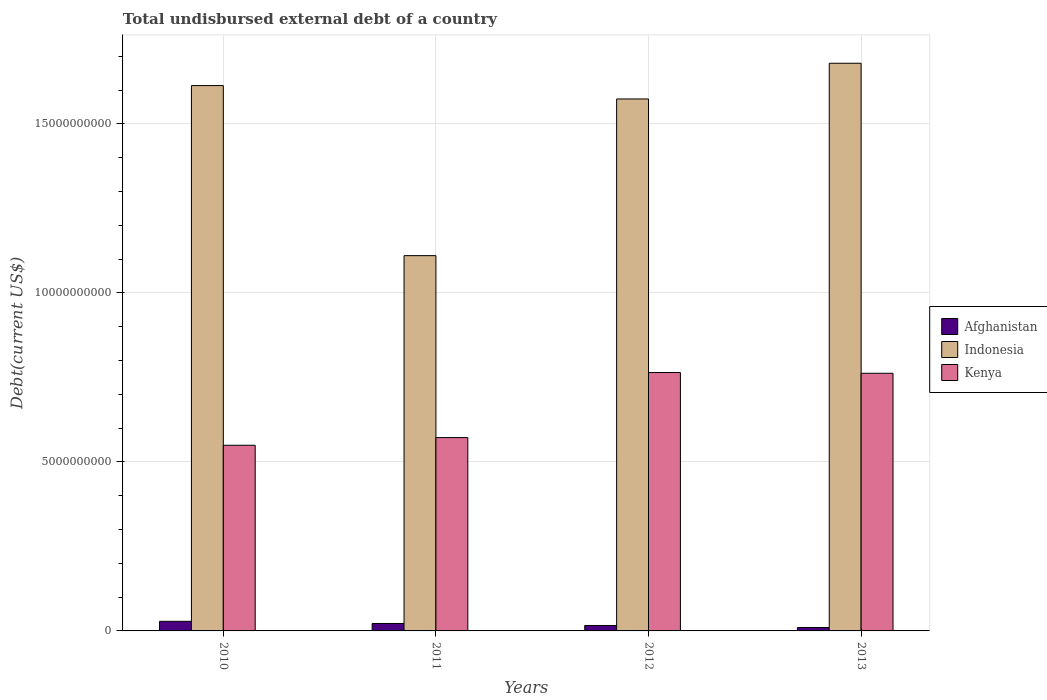How many different coloured bars are there?
Your response must be concise. 3. How many groups of bars are there?
Provide a short and direct response. 4. Are the number of bars per tick equal to the number of legend labels?
Ensure brevity in your answer.  Yes. Are the number of bars on each tick of the X-axis equal?
Ensure brevity in your answer.  Yes. How many bars are there on the 1st tick from the left?
Offer a very short reply. 3. How many bars are there on the 2nd tick from the right?
Your response must be concise. 3. In how many cases, is the number of bars for a given year not equal to the number of legend labels?
Offer a terse response. 0. What is the total undisbursed external debt in Afghanistan in 2010?
Keep it short and to the point. 2.84e+08. Across all years, what is the maximum total undisbursed external debt in Afghanistan?
Keep it short and to the point. 2.84e+08. Across all years, what is the minimum total undisbursed external debt in Afghanistan?
Ensure brevity in your answer.  1.02e+08. In which year was the total undisbursed external debt in Afghanistan maximum?
Your answer should be very brief. 2010. What is the total total undisbursed external debt in Kenya in the graph?
Keep it short and to the point. 2.65e+1. What is the difference between the total undisbursed external debt in Afghanistan in 2010 and that in 2011?
Offer a terse response. 6.44e+07. What is the difference between the total undisbursed external debt in Kenya in 2010 and the total undisbursed external debt in Afghanistan in 2012?
Your answer should be compact. 5.33e+09. What is the average total undisbursed external debt in Indonesia per year?
Your response must be concise. 1.49e+1. In the year 2011, what is the difference between the total undisbursed external debt in Indonesia and total undisbursed external debt in Kenya?
Offer a very short reply. 5.38e+09. In how many years, is the total undisbursed external debt in Afghanistan greater than 1000000000 US$?
Keep it short and to the point. 0. What is the ratio of the total undisbursed external debt in Afghanistan in 2010 to that in 2013?
Offer a terse response. 2.8. Is the difference between the total undisbursed external debt in Indonesia in 2011 and 2013 greater than the difference between the total undisbursed external debt in Kenya in 2011 and 2013?
Offer a terse response. No. What is the difference between the highest and the second highest total undisbursed external debt in Afghanistan?
Your answer should be very brief. 6.44e+07. What is the difference between the highest and the lowest total undisbursed external debt in Kenya?
Provide a succinct answer. 2.15e+09. In how many years, is the total undisbursed external debt in Afghanistan greater than the average total undisbursed external debt in Afghanistan taken over all years?
Your response must be concise. 2. What does the 2nd bar from the left in 2010 represents?
Give a very brief answer. Indonesia. Are all the bars in the graph horizontal?
Ensure brevity in your answer.  No. How many years are there in the graph?
Offer a very short reply. 4. What is the difference between two consecutive major ticks on the Y-axis?
Provide a short and direct response. 5.00e+09. Are the values on the major ticks of Y-axis written in scientific E-notation?
Your answer should be compact. No. Does the graph contain grids?
Make the answer very short. Yes. Where does the legend appear in the graph?
Give a very brief answer. Center right. How are the legend labels stacked?
Offer a very short reply. Vertical. What is the title of the graph?
Your response must be concise. Total undisbursed external debt of a country. Does "Kyrgyz Republic" appear as one of the legend labels in the graph?
Your answer should be very brief. No. What is the label or title of the X-axis?
Offer a terse response. Years. What is the label or title of the Y-axis?
Make the answer very short. Debt(current US$). What is the Debt(current US$) of Afghanistan in 2010?
Give a very brief answer. 2.84e+08. What is the Debt(current US$) of Indonesia in 2010?
Provide a short and direct response. 1.61e+1. What is the Debt(current US$) of Kenya in 2010?
Your answer should be very brief. 5.49e+09. What is the Debt(current US$) of Afghanistan in 2011?
Your answer should be very brief. 2.20e+08. What is the Debt(current US$) in Indonesia in 2011?
Offer a very short reply. 1.11e+1. What is the Debt(current US$) in Kenya in 2011?
Ensure brevity in your answer.  5.72e+09. What is the Debt(current US$) in Afghanistan in 2012?
Make the answer very short. 1.61e+08. What is the Debt(current US$) in Indonesia in 2012?
Provide a short and direct response. 1.57e+1. What is the Debt(current US$) of Kenya in 2012?
Your answer should be very brief. 7.64e+09. What is the Debt(current US$) in Afghanistan in 2013?
Your answer should be compact. 1.02e+08. What is the Debt(current US$) in Indonesia in 2013?
Your answer should be compact. 1.68e+1. What is the Debt(current US$) in Kenya in 2013?
Your response must be concise. 7.62e+09. Across all years, what is the maximum Debt(current US$) of Afghanistan?
Ensure brevity in your answer.  2.84e+08. Across all years, what is the maximum Debt(current US$) of Indonesia?
Give a very brief answer. 1.68e+1. Across all years, what is the maximum Debt(current US$) of Kenya?
Offer a terse response. 7.64e+09. Across all years, what is the minimum Debt(current US$) of Afghanistan?
Your answer should be compact. 1.02e+08. Across all years, what is the minimum Debt(current US$) of Indonesia?
Your answer should be compact. 1.11e+1. Across all years, what is the minimum Debt(current US$) in Kenya?
Offer a very short reply. 5.49e+09. What is the total Debt(current US$) in Afghanistan in the graph?
Keep it short and to the point. 7.67e+08. What is the total Debt(current US$) in Indonesia in the graph?
Provide a short and direct response. 5.98e+1. What is the total Debt(current US$) of Kenya in the graph?
Your response must be concise. 2.65e+1. What is the difference between the Debt(current US$) of Afghanistan in 2010 and that in 2011?
Offer a very short reply. 6.44e+07. What is the difference between the Debt(current US$) in Indonesia in 2010 and that in 2011?
Your answer should be very brief. 5.03e+09. What is the difference between the Debt(current US$) in Kenya in 2010 and that in 2011?
Offer a terse response. -2.27e+08. What is the difference between the Debt(current US$) in Afghanistan in 2010 and that in 2012?
Keep it short and to the point. 1.23e+08. What is the difference between the Debt(current US$) in Indonesia in 2010 and that in 2012?
Provide a succinct answer. 3.96e+08. What is the difference between the Debt(current US$) in Kenya in 2010 and that in 2012?
Offer a very short reply. -2.15e+09. What is the difference between the Debt(current US$) in Afghanistan in 2010 and that in 2013?
Provide a short and direct response. 1.83e+08. What is the difference between the Debt(current US$) of Indonesia in 2010 and that in 2013?
Offer a very short reply. -6.60e+08. What is the difference between the Debt(current US$) of Kenya in 2010 and that in 2013?
Offer a terse response. -2.13e+09. What is the difference between the Debt(current US$) of Afghanistan in 2011 and that in 2012?
Make the answer very short. 5.87e+07. What is the difference between the Debt(current US$) of Indonesia in 2011 and that in 2012?
Your answer should be very brief. -4.64e+09. What is the difference between the Debt(current US$) of Kenya in 2011 and that in 2012?
Offer a terse response. -1.92e+09. What is the difference between the Debt(current US$) in Afghanistan in 2011 and that in 2013?
Your answer should be very brief. 1.18e+08. What is the difference between the Debt(current US$) in Indonesia in 2011 and that in 2013?
Give a very brief answer. -5.69e+09. What is the difference between the Debt(current US$) of Kenya in 2011 and that in 2013?
Keep it short and to the point. -1.90e+09. What is the difference between the Debt(current US$) in Afghanistan in 2012 and that in 2013?
Your answer should be very brief. 5.97e+07. What is the difference between the Debt(current US$) in Indonesia in 2012 and that in 2013?
Provide a succinct answer. -1.06e+09. What is the difference between the Debt(current US$) of Kenya in 2012 and that in 2013?
Keep it short and to the point. 2.23e+07. What is the difference between the Debt(current US$) of Afghanistan in 2010 and the Debt(current US$) of Indonesia in 2011?
Offer a very short reply. -1.08e+1. What is the difference between the Debt(current US$) in Afghanistan in 2010 and the Debt(current US$) in Kenya in 2011?
Your response must be concise. -5.44e+09. What is the difference between the Debt(current US$) in Indonesia in 2010 and the Debt(current US$) in Kenya in 2011?
Ensure brevity in your answer.  1.04e+1. What is the difference between the Debt(current US$) in Afghanistan in 2010 and the Debt(current US$) in Indonesia in 2012?
Offer a terse response. -1.55e+1. What is the difference between the Debt(current US$) of Afghanistan in 2010 and the Debt(current US$) of Kenya in 2012?
Your response must be concise. -7.36e+09. What is the difference between the Debt(current US$) of Indonesia in 2010 and the Debt(current US$) of Kenya in 2012?
Your response must be concise. 8.49e+09. What is the difference between the Debt(current US$) of Afghanistan in 2010 and the Debt(current US$) of Indonesia in 2013?
Your answer should be very brief. -1.65e+1. What is the difference between the Debt(current US$) in Afghanistan in 2010 and the Debt(current US$) in Kenya in 2013?
Your response must be concise. -7.34e+09. What is the difference between the Debt(current US$) in Indonesia in 2010 and the Debt(current US$) in Kenya in 2013?
Provide a succinct answer. 8.51e+09. What is the difference between the Debt(current US$) in Afghanistan in 2011 and the Debt(current US$) in Indonesia in 2012?
Provide a succinct answer. -1.55e+1. What is the difference between the Debt(current US$) of Afghanistan in 2011 and the Debt(current US$) of Kenya in 2012?
Your answer should be compact. -7.42e+09. What is the difference between the Debt(current US$) in Indonesia in 2011 and the Debt(current US$) in Kenya in 2012?
Your response must be concise. 3.46e+09. What is the difference between the Debt(current US$) in Afghanistan in 2011 and the Debt(current US$) in Indonesia in 2013?
Keep it short and to the point. -1.66e+1. What is the difference between the Debt(current US$) in Afghanistan in 2011 and the Debt(current US$) in Kenya in 2013?
Keep it short and to the point. -7.40e+09. What is the difference between the Debt(current US$) of Indonesia in 2011 and the Debt(current US$) of Kenya in 2013?
Offer a terse response. 3.48e+09. What is the difference between the Debt(current US$) in Afghanistan in 2012 and the Debt(current US$) in Indonesia in 2013?
Your answer should be compact. -1.66e+1. What is the difference between the Debt(current US$) of Afghanistan in 2012 and the Debt(current US$) of Kenya in 2013?
Your answer should be very brief. -7.46e+09. What is the difference between the Debt(current US$) of Indonesia in 2012 and the Debt(current US$) of Kenya in 2013?
Your answer should be very brief. 8.12e+09. What is the average Debt(current US$) of Afghanistan per year?
Ensure brevity in your answer.  1.92e+08. What is the average Debt(current US$) in Indonesia per year?
Provide a short and direct response. 1.49e+1. What is the average Debt(current US$) in Kenya per year?
Ensure brevity in your answer.  6.62e+09. In the year 2010, what is the difference between the Debt(current US$) of Afghanistan and Debt(current US$) of Indonesia?
Your answer should be compact. -1.58e+1. In the year 2010, what is the difference between the Debt(current US$) of Afghanistan and Debt(current US$) of Kenya?
Offer a very short reply. -5.21e+09. In the year 2010, what is the difference between the Debt(current US$) in Indonesia and Debt(current US$) in Kenya?
Offer a very short reply. 1.06e+1. In the year 2011, what is the difference between the Debt(current US$) in Afghanistan and Debt(current US$) in Indonesia?
Provide a short and direct response. -1.09e+1. In the year 2011, what is the difference between the Debt(current US$) of Afghanistan and Debt(current US$) of Kenya?
Offer a very short reply. -5.50e+09. In the year 2011, what is the difference between the Debt(current US$) in Indonesia and Debt(current US$) in Kenya?
Give a very brief answer. 5.38e+09. In the year 2012, what is the difference between the Debt(current US$) in Afghanistan and Debt(current US$) in Indonesia?
Keep it short and to the point. -1.56e+1. In the year 2012, what is the difference between the Debt(current US$) of Afghanistan and Debt(current US$) of Kenya?
Ensure brevity in your answer.  -7.48e+09. In the year 2012, what is the difference between the Debt(current US$) in Indonesia and Debt(current US$) in Kenya?
Ensure brevity in your answer.  8.09e+09. In the year 2013, what is the difference between the Debt(current US$) of Afghanistan and Debt(current US$) of Indonesia?
Your answer should be very brief. -1.67e+1. In the year 2013, what is the difference between the Debt(current US$) in Afghanistan and Debt(current US$) in Kenya?
Keep it short and to the point. -7.52e+09. In the year 2013, what is the difference between the Debt(current US$) of Indonesia and Debt(current US$) of Kenya?
Provide a short and direct response. 9.17e+09. What is the ratio of the Debt(current US$) of Afghanistan in 2010 to that in 2011?
Offer a very short reply. 1.29. What is the ratio of the Debt(current US$) in Indonesia in 2010 to that in 2011?
Your answer should be very brief. 1.45. What is the ratio of the Debt(current US$) in Kenya in 2010 to that in 2011?
Offer a very short reply. 0.96. What is the ratio of the Debt(current US$) in Afghanistan in 2010 to that in 2012?
Your answer should be compact. 1.76. What is the ratio of the Debt(current US$) in Indonesia in 2010 to that in 2012?
Your answer should be very brief. 1.03. What is the ratio of the Debt(current US$) of Kenya in 2010 to that in 2012?
Your response must be concise. 0.72. What is the ratio of the Debt(current US$) of Afghanistan in 2010 to that in 2013?
Keep it short and to the point. 2.8. What is the ratio of the Debt(current US$) in Indonesia in 2010 to that in 2013?
Offer a terse response. 0.96. What is the ratio of the Debt(current US$) of Kenya in 2010 to that in 2013?
Provide a succinct answer. 0.72. What is the ratio of the Debt(current US$) of Afghanistan in 2011 to that in 2012?
Offer a very short reply. 1.36. What is the ratio of the Debt(current US$) in Indonesia in 2011 to that in 2012?
Ensure brevity in your answer.  0.71. What is the ratio of the Debt(current US$) in Kenya in 2011 to that in 2012?
Your answer should be compact. 0.75. What is the ratio of the Debt(current US$) of Afghanistan in 2011 to that in 2013?
Ensure brevity in your answer.  2.17. What is the ratio of the Debt(current US$) in Indonesia in 2011 to that in 2013?
Keep it short and to the point. 0.66. What is the ratio of the Debt(current US$) in Kenya in 2011 to that in 2013?
Keep it short and to the point. 0.75. What is the ratio of the Debt(current US$) of Afghanistan in 2012 to that in 2013?
Your answer should be very brief. 1.59. What is the ratio of the Debt(current US$) in Indonesia in 2012 to that in 2013?
Offer a very short reply. 0.94. What is the difference between the highest and the second highest Debt(current US$) of Afghanistan?
Your answer should be compact. 6.44e+07. What is the difference between the highest and the second highest Debt(current US$) in Indonesia?
Your answer should be very brief. 6.60e+08. What is the difference between the highest and the second highest Debt(current US$) of Kenya?
Provide a short and direct response. 2.23e+07. What is the difference between the highest and the lowest Debt(current US$) in Afghanistan?
Your answer should be compact. 1.83e+08. What is the difference between the highest and the lowest Debt(current US$) in Indonesia?
Offer a terse response. 5.69e+09. What is the difference between the highest and the lowest Debt(current US$) of Kenya?
Keep it short and to the point. 2.15e+09. 